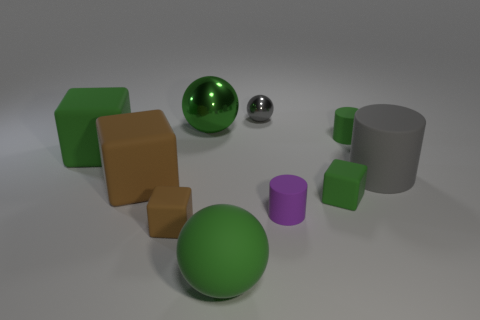Subtract 1 cubes. How many cubes are left? 3 Subtract all balls. How many objects are left? 7 Add 7 gray metallic cubes. How many gray metallic cubes exist? 7 Subtract 0 red cylinders. How many objects are left? 10 Subtract all brown metallic things. Subtract all metallic balls. How many objects are left? 8 Add 5 gray matte cylinders. How many gray matte cylinders are left? 6 